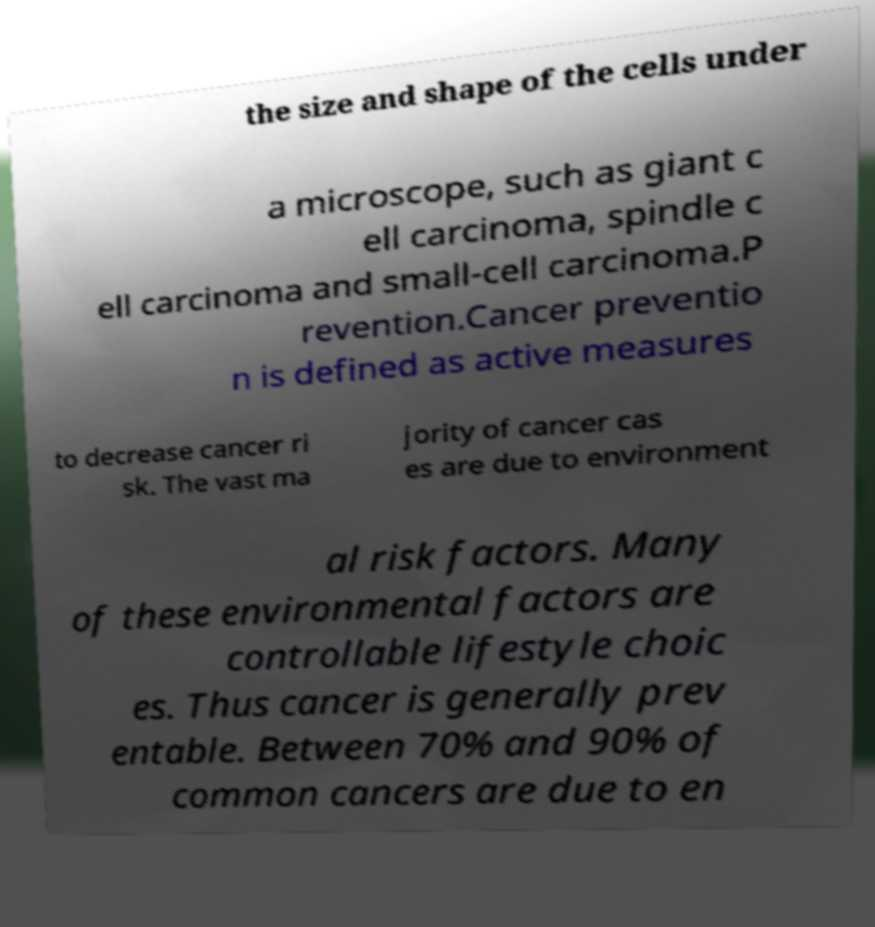Could you extract and type out the text from this image? the size and shape of the cells under a microscope, such as giant c ell carcinoma, spindle c ell carcinoma and small-cell carcinoma.P revention.Cancer preventio n is defined as active measures to decrease cancer ri sk. The vast ma jority of cancer cas es are due to environment al risk factors. Many of these environmental factors are controllable lifestyle choic es. Thus cancer is generally prev entable. Between 70% and 90% of common cancers are due to en 